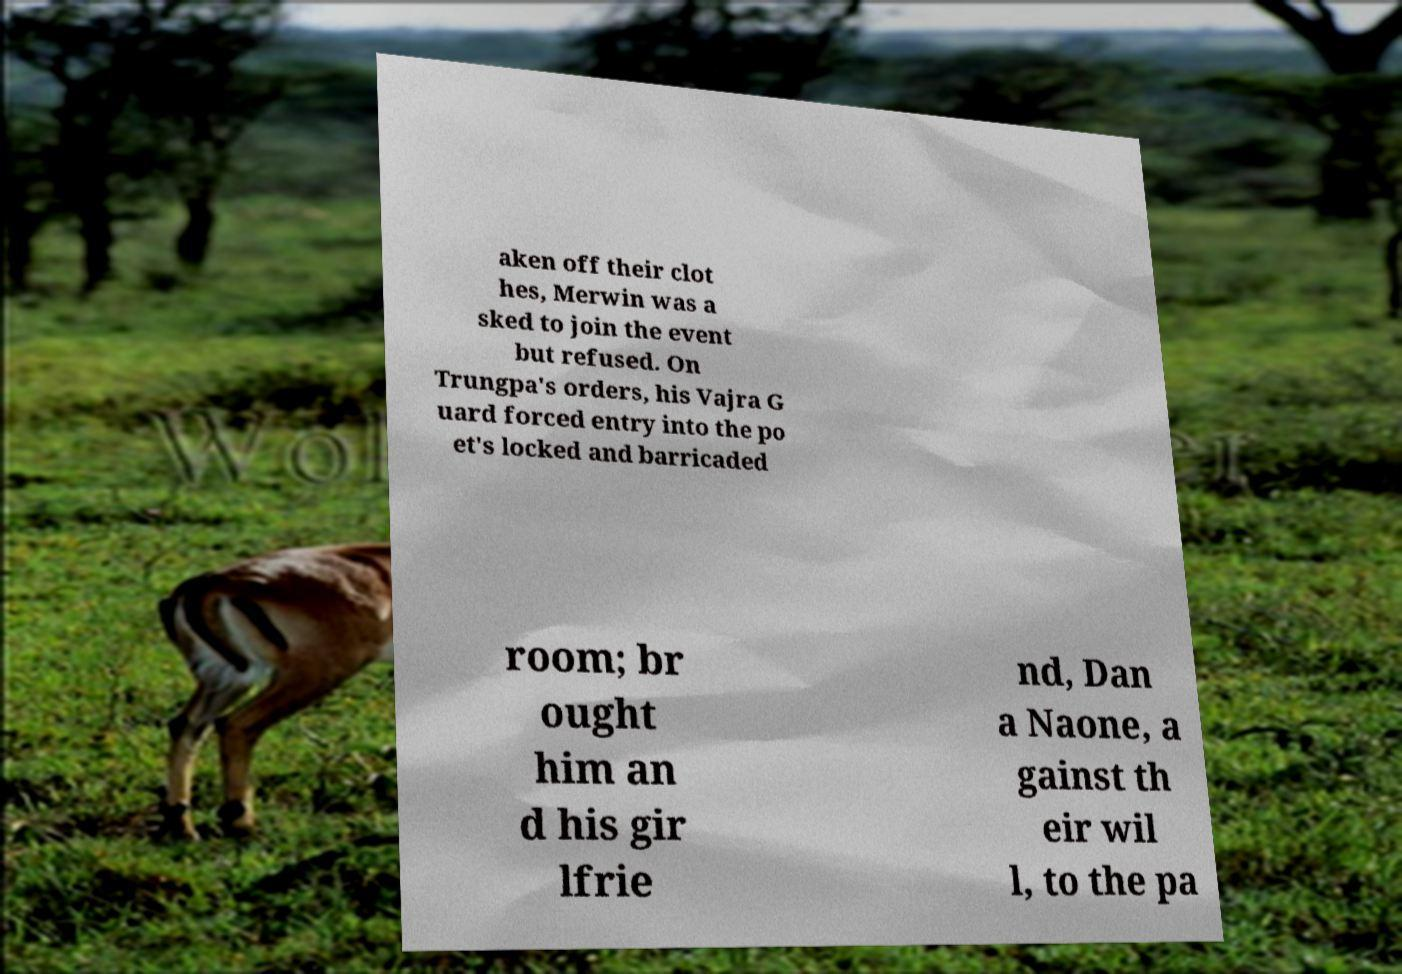What messages or text are displayed in this image? I need them in a readable, typed format. aken off their clot hes, Merwin was a sked to join the event but refused. On Trungpa's orders, his Vajra G uard forced entry into the po et's locked and barricaded room; br ought him an d his gir lfrie nd, Dan a Naone, a gainst th eir wil l, to the pa 